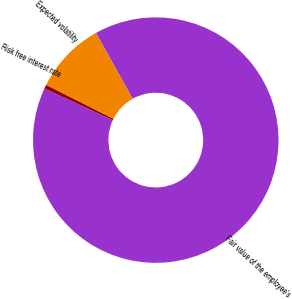Convert chart. <chart><loc_0><loc_0><loc_500><loc_500><pie_chart><fcel>Fair value of the employee's<fcel>Risk free interest rate<fcel>Expected volatility<nl><fcel>90.02%<fcel>0.52%<fcel>9.46%<nl></chart> 